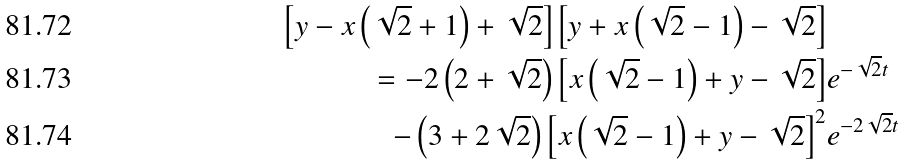<formula> <loc_0><loc_0><loc_500><loc_500>\left [ y - x \left ( \sqrt { 2 } + 1 \right ) + \sqrt { 2 } \right ] \left [ y + x \left ( \sqrt { 2 } - 1 \right ) - \sqrt { 2 } \right ] \\ = - 2 \left ( 2 + \sqrt { 2 } \right ) \left [ x \left ( \sqrt { 2 } - 1 \right ) + y - \sqrt { 2 } \right ] & e ^ { - \sqrt { 2 } t } \\ - \left ( 3 + 2 \sqrt { 2 } \right ) \left [ x \left ( \sqrt { 2 } - 1 \right ) + y - \sqrt { 2 } \right ] ^ { 2 } & e ^ { - 2 \sqrt { 2 } t }</formula> 